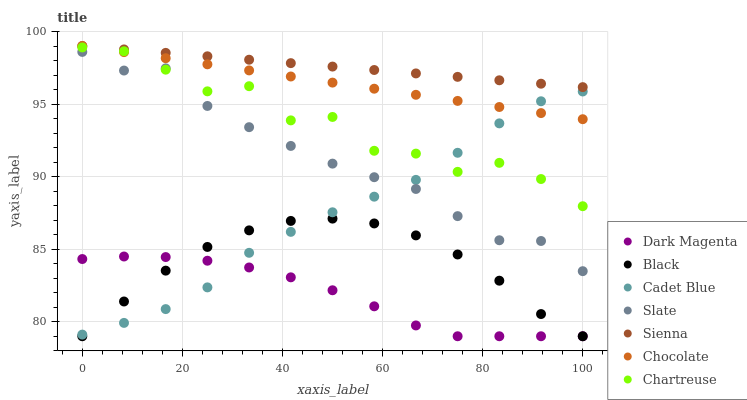Does Dark Magenta have the minimum area under the curve?
Answer yes or no. Yes. Does Sienna have the maximum area under the curve?
Answer yes or no. Yes. Does Slate have the minimum area under the curve?
Answer yes or no. No. Does Slate have the maximum area under the curve?
Answer yes or no. No. Is Sienna the smoothest?
Answer yes or no. Yes. Is Chartreuse the roughest?
Answer yes or no. Yes. Is Dark Magenta the smoothest?
Answer yes or no. No. Is Dark Magenta the roughest?
Answer yes or no. No. Does Dark Magenta have the lowest value?
Answer yes or no. Yes. Does Slate have the lowest value?
Answer yes or no. No. Does Sienna have the highest value?
Answer yes or no. Yes. Does Slate have the highest value?
Answer yes or no. No. Is Dark Magenta less than Sienna?
Answer yes or no. Yes. Is Sienna greater than Dark Magenta?
Answer yes or no. Yes. Does Chartreuse intersect Chocolate?
Answer yes or no. Yes. Is Chartreuse less than Chocolate?
Answer yes or no. No. Is Chartreuse greater than Chocolate?
Answer yes or no. No. Does Dark Magenta intersect Sienna?
Answer yes or no. No. 